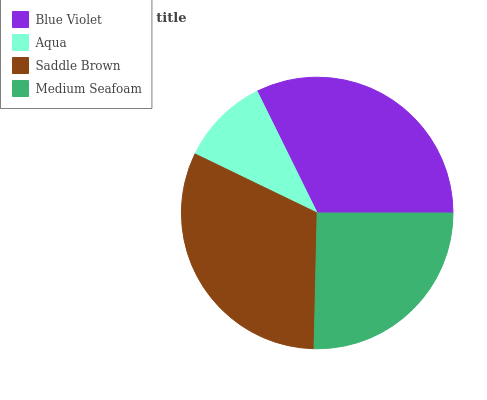Is Aqua the minimum?
Answer yes or no. Yes. Is Blue Violet the maximum?
Answer yes or no. Yes. Is Saddle Brown the minimum?
Answer yes or no. No. Is Saddle Brown the maximum?
Answer yes or no. No. Is Saddle Brown greater than Aqua?
Answer yes or no. Yes. Is Aqua less than Saddle Brown?
Answer yes or no. Yes. Is Aqua greater than Saddle Brown?
Answer yes or no. No. Is Saddle Brown less than Aqua?
Answer yes or no. No. Is Saddle Brown the high median?
Answer yes or no. Yes. Is Medium Seafoam the low median?
Answer yes or no. Yes. Is Aqua the high median?
Answer yes or no. No. Is Aqua the low median?
Answer yes or no. No. 